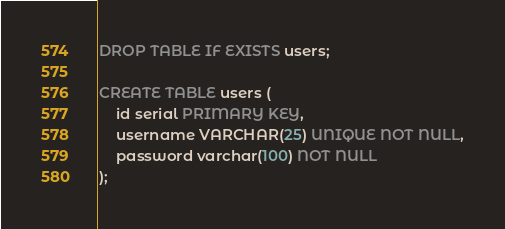<code> <loc_0><loc_0><loc_500><loc_500><_SQL_>DROP TABLE IF EXISTS users;

CREATE TABLE users (
    id serial PRIMARY KEY,
    username VARCHAR(25) UNIQUE NOT NULL,
    password varchar(100) NOT NULL
);
</code> 